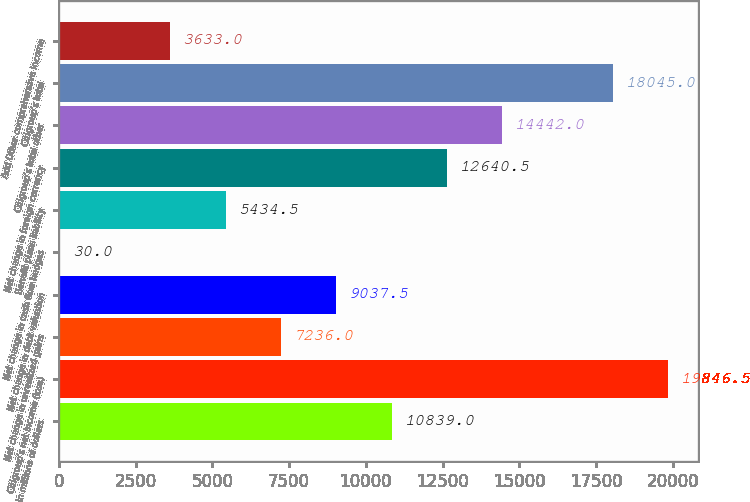<chart> <loc_0><loc_0><loc_500><loc_500><bar_chart><fcel>In millions of dollars<fcel>Citigroup's net income (loss)<fcel>Net change in unrealized gains<fcel>Net change in debt valuation<fcel>Net change in cash flow hedges<fcel>Benefit plans liability<fcel>Net change in foreign currency<fcel>Citigroup's total other<fcel>Citigroup's total<fcel>Add Other comprehensive income<nl><fcel>10839<fcel>19846.5<fcel>7236<fcel>9037.5<fcel>30<fcel>5434.5<fcel>12640.5<fcel>14442<fcel>18045<fcel>3633<nl></chart> 